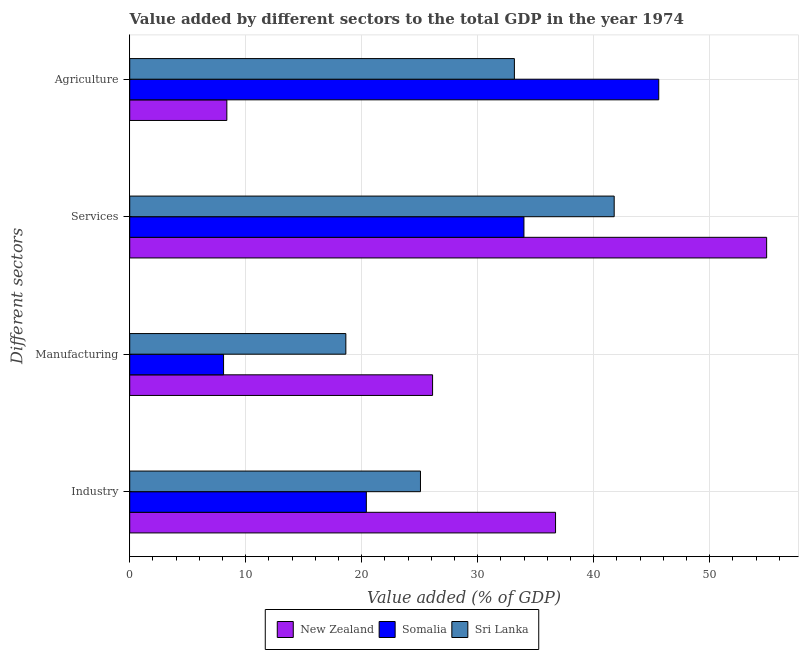How many different coloured bars are there?
Provide a short and direct response. 3. How many groups of bars are there?
Your answer should be compact. 4. Are the number of bars per tick equal to the number of legend labels?
Your response must be concise. Yes. How many bars are there on the 2nd tick from the bottom?
Provide a short and direct response. 3. What is the label of the 4th group of bars from the top?
Provide a succinct answer. Industry. What is the value added by manufacturing sector in New Zealand?
Your response must be concise. 26.11. Across all countries, what is the maximum value added by services sector?
Keep it short and to the point. 54.91. Across all countries, what is the minimum value added by services sector?
Make the answer very short. 33.99. In which country was the value added by services sector maximum?
Your response must be concise. New Zealand. In which country was the value added by services sector minimum?
Ensure brevity in your answer.  Somalia. What is the total value added by agricultural sector in the graph?
Offer a terse response. 87.15. What is the difference between the value added by industrial sector in Somalia and that in New Zealand?
Offer a very short reply. -16.31. What is the difference between the value added by industrial sector in Sri Lanka and the value added by manufacturing sector in Somalia?
Provide a short and direct response. 16.98. What is the average value added by agricultural sector per country?
Your response must be concise. 29.05. What is the difference between the value added by manufacturing sector and value added by services sector in Sri Lanka?
Offer a terse response. -23.14. In how many countries, is the value added by agricultural sector greater than 6 %?
Give a very brief answer. 3. What is the ratio of the value added by services sector in Sri Lanka to that in New Zealand?
Offer a terse response. 0.76. Is the difference between the value added by agricultural sector in New Zealand and Sri Lanka greater than the difference between the value added by industrial sector in New Zealand and Sri Lanka?
Provide a short and direct response. No. What is the difference between the highest and the second highest value added by agricultural sector?
Make the answer very short. 12.45. What is the difference between the highest and the lowest value added by services sector?
Give a very brief answer. 20.93. Is the sum of the value added by industrial sector in New Zealand and Somalia greater than the maximum value added by manufacturing sector across all countries?
Ensure brevity in your answer.  Yes. Is it the case that in every country, the sum of the value added by services sector and value added by agricultural sector is greater than the sum of value added by manufacturing sector and value added by industrial sector?
Keep it short and to the point. Yes. What does the 2nd bar from the top in Agriculture represents?
Make the answer very short. Somalia. What does the 1st bar from the bottom in Agriculture represents?
Provide a succinct answer. New Zealand. How many bars are there?
Your response must be concise. 12. Are all the bars in the graph horizontal?
Your answer should be very brief. Yes. How many countries are there in the graph?
Make the answer very short. 3. What is the difference between two consecutive major ticks on the X-axis?
Make the answer very short. 10. Are the values on the major ticks of X-axis written in scientific E-notation?
Your response must be concise. No. Does the graph contain any zero values?
Keep it short and to the point. No. Does the graph contain grids?
Provide a short and direct response. Yes. Where does the legend appear in the graph?
Give a very brief answer. Bottom center. What is the title of the graph?
Your answer should be compact. Value added by different sectors to the total GDP in the year 1974. Does "Canada" appear as one of the legend labels in the graph?
Keep it short and to the point. No. What is the label or title of the X-axis?
Give a very brief answer. Value added (% of GDP). What is the label or title of the Y-axis?
Make the answer very short. Different sectors. What is the Value added (% of GDP) in New Zealand in Industry?
Ensure brevity in your answer.  36.71. What is the Value added (% of GDP) in Somalia in Industry?
Provide a short and direct response. 20.4. What is the Value added (% of GDP) of Sri Lanka in Industry?
Provide a succinct answer. 25.07. What is the Value added (% of GDP) in New Zealand in Manufacturing?
Provide a succinct answer. 26.11. What is the Value added (% of GDP) of Somalia in Manufacturing?
Give a very brief answer. 8.09. What is the Value added (% of GDP) in Sri Lanka in Manufacturing?
Keep it short and to the point. 18.63. What is the Value added (% of GDP) of New Zealand in Services?
Your answer should be very brief. 54.91. What is the Value added (% of GDP) of Somalia in Services?
Ensure brevity in your answer.  33.99. What is the Value added (% of GDP) in Sri Lanka in Services?
Your response must be concise. 41.77. What is the Value added (% of GDP) of New Zealand in Agriculture?
Your response must be concise. 8.37. What is the Value added (% of GDP) of Somalia in Agriculture?
Keep it short and to the point. 45.61. What is the Value added (% of GDP) in Sri Lanka in Agriculture?
Your answer should be very brief. 33.16. Across all Different sectors, what is the maximum Value added (% of GDP) of New Zealand?
Ensure brevity in your answer.  54.91. Across all Different sectors, what is the maximum Value added (% of GDP) in Somalia?
Offer a very short reply. 45.61. Across all Different sectors, what is the maximum Value added (% of GDP) in Sri Lanka?
Keep it short and to the point. 41.77. Across all Different sectors, what is the minimum Value added (% of GDP) in New Zealand?
Provide a short and direct response. 8.37. Across all Different sectors, what is the minimum Value added (% of GDP) in Somalia?
Provide a short and direct response. 8.09. Across all Different sectors, what is the minimum Value added (% of GDP) in Sri Lanka?
Make the answer very short. 18.63. What is the total Value added (% of GDP) in New Zealand in the graph?
Make the answer very short. 126.11. What is the total Value added (% of GDP) in Somalia in the graph?
Ensure brevity in your answer.  108.09. What is the total Value added (% of GDP) of Sri Lanka in the graph?
Ensure brevity in your answer.  118.63. What is the difference between the Value added (% of GDP) in New Zealand in Industry and that in Manufacturing?
Ensure brevity in your answer.  10.6. What is the difference between the Value added (% of GDP) in Somalia in Industry and that in Manufacturing?
Your response must be concise. 12.31. What is the difference between the Value added (% of GDP) of Sri Lanka in Industry and that in Manufacturing?
Offer a very short reply. 6.43. What is the difference between the Value added (% of GDP) of New Zealand in Industry and that in Services?
Give a very brief answer. -18.2. What is the difference between the Value added (% of GDP) in Somalia in Industry and that in Services?
Your response must be concise. -13.59. What is the difference between the Value added (% of GDP) of Sri Lanka in Industry and that in Services?
Your response must be concise. -16.7. What is the difference between the Value added (% of GDP) in New Zealand in Industry and that in Agriculture?
Offer a very short reply. 28.34. What is the difference between the Value added (% of GDP) in Somalia in Industry and that in Agriculture?
Your answer should be very brief. -25.21. What is the difference between the Value added (% of GDP) in Sri Lanka in Industry and that in Agriculture?
Provide a short and direct response. -8.1. What is the difference between the Value added (% of GDP) of New Zealand in Manufacturing and that in Services?
Your answer should be very brief. -28.8. What is the difference between the Value added (% of GDP) of Somalia in Manufacturing and that in Services?
Provide a short and direct response. -25.9. What is the difference between the Value added (% of GDP) in Sri Lanka in Manufacturing and that in Services?
Offer a terse response. -23.14. What is the difference between the Value added (% of GDP) of New Zealand in Manufacturing and that in Agriculture?
Make the answer very short. 17.74. What is the difference between the Value added (% of GDP) of Somalia in Manufacturing and that in Agriculture?
Provide a succinct answer. -37.52. What is the difference between the Value added (% of GDP) in Sri Lanka in Manufacturing and that in Agriculture?
Offer a very short reply. -14.53. What is the difference between the Value added (% of GDP) of New Zealand in Services and that in Agriculture?
Your answer should be compact. 46.54. What is the difference between the Value added (% of GDP) in Somalia in Services and that in Agriculture?
Provide a short and direct response. -11.62. What is the difference between the Value added (% of GDP) of Sri Lanka in Services and that in Agriculture?
Your response must be concise. 8.6. What is the difference between the Value added (% of GDP) of New Zealand in Industry and the Value added (% of GDP) of Somalia in Manufacturing?
Make the answer very short. 28.62. What is the difference between the Value added (% of GDP) in New Zealand in Industry and the Value added (% of GDP) in Sri Lanka in Manufacturing?
Provide a short and direct response. 18.08. What is the difference between the Value added (% of GDP) of Somalia in Industry and the Value added (% of GDP) of Sri Lanka in Manufacturing?
Your answer should be compact. 1.77. What is the difference between the Value added (% of GDP) in New Zealand in Industry and the Value added (% of GDP) in Somalia in Services?
Give a very brief answer. 2.73. What is the difference between the Value added (% of GDP) in New Zealand in Industry and the Value added (% of GDP) in Sri Lanka in Services?
Provide a short and direct response. -5.06. What is the difference between the Value added (% of GDP) in Somalia in Industry and the Value added (% of GDP) in Sri Lanka in Services?
Ensure brevity in your answer.  -21.37. What is the difference between the Value added (% of GDP) of New Zealand in Industry and the Value added (% of GDP) of Somalia in Agriculture?
Your response must be concise. -8.9. What is the difference between the Value added (% of GDP) of New Zealand in Industry and the Value added (% of GDP) of Sri Lanka in Agriculture?
Provide a succinct answer. 3.55. What is the difference between the Value added (% of GDP) in Somalia in Industry and the Value added (% of GDP) in Sri Lanka in Agriculture?
Keep it short and to the point. -12.76. What is the difference between the Value added (% of GDP) in New Zealand in Manufacturing and the Value added (% of GDP) in Somalia in Services?
Make the answer very short. -7.88. What is the difference between the Value added (% of GDP) of New Zealand in Manufacturing and the Value added (% of GDP) of Sri Lanka in Services?
Your response must be concise. -15.66. What is the difference between the Value added (% of GDP) in Somalia in Manufacturing and the Value added (% of GDP) in Sri Lanka in Services?
Your response must be concise. -33.68. What is the difference between the Value added (% of GDP) in New Zealand in Manufacturing and the Value added (% of GDP) in Somalia in Agriculture?
Your response must be concise. -19.5. What is the difference between the Value added (% of GDP) of New Zealand in Manufacturing and the Value added (% of GDP) of Sri Lanka in Agriculture?
Offer a very short reply. -7.05. What is the difference between the Value added (% of GDP) of Somalia in Manufacturing and the Value added (% of GDP) of Sri Lanka in Agriculture?
Provide a short and direct response. -25.07. What is the difference between the Value added (% of GDP) of New Zealand in Services and the Value added (% of GDP) of Somalia in Agriculture?
Provide a succinct answer. 9.3. What is the difference between the Value added (% of GDP) in New Zealand in Services and the Value added (% of GDP) in Sri Lanka in Agriculture?
Keep it short and to the point. 21.75. What is the difference between the Value added (% of GDP) of Somalia in Services and the Value added (% of GDP) of Sri Lanka in Agriculture?
Your response must be concise. 0.82. What is the average Value added (% of GDP) in New Zealand per Different sectors?
Ensure brevity in your answer.  31.53. What is the average Value added (% of GDP) of Somalia per Different sectors?
Offer a terse response. 27.02. What is the average Value added (% of GDP) of Sri Lanka per Different sectors?
Ensure brevity in your answer.  29.66. What is the difference between the Value added (% of GDP) of New Zealand and Value added (% of GDP) of Somalia in Industry?
Your response must be concise. 16.31. What is the difference between the Value added (% of GDP) of New Zealand and Value added (% of GDP) of Sri Lanka in Industry?
Your answer should be very brief. 11.65. What is the difference between the Value added (% of GDP) in Somalia and Value added (% of GDP) in Sri Lanka in Industry?
Give a very brief answer. -4.67. What is the difference between the Value added (% of GDP) of New Zealand and Value added (% of GDP) of Somalia in Manufacturing?
Make the answer very short. 18.02. What is the difference between the Value added (% of GDP) in New Zealand and Value added (% of GDP) in Sri Lanka in Manufacturing?
Provide a short and direct response. 7.48. What is the difference between the Value added (% of GDP) in Somalia and Value added (% of GDP) in Sri Lanka in Manufacturing?
Ensure brevity in your answer.  -10.54. What is the difference between the Value added (% of GDP) of New Zealand and Value added (% of GDP) of Somalia in Services?
Your answer should be compact. 20.93. What is the difference between the Value added (% of GDP) of New Zealand and Value added (% of GDP) of Sri Lanka in Services?
Provide a short and direct response. 13.14. What is the difference between the Value added (% of GDP) of Somalia and Value added (% of GDP) of Sri Lanka in Services?
Keep it short and to the point. -7.78. What is the difference between the Value added (% of GDP) in New Zealand and Value added (% of GDP) in Somalia in Agriculture?
Give a very brief answer. -37.24. What is the difference between the Value added (% of GDP) of New Zealand and Value added (% of GDP) of Sri Lanka in Agriculture?
Offer a terse response. -24.79. What is the difference between the Value added (% of GDP) of Somalia and Value added (% of GDP) of Sri Lanka in Agriculture?
Your response must be concise. 12.45. What is the ratio of the Value added (% of GDP) in New Zealand in Industry to that in Manufacturing?
Provide a succinct answer. 1.41. What is the ratio of the Value added (% of GDP) of Somalia in Industry to that in Manufacturing?
Make the answer very short. 2.52. What is the ratio of the Value added (% of GDP) of Sri Lanka in Industry to that in Manufacturing?
Provide a succinct answer. 1.35. What is the ratio of the Value added (% of GDP) in New Zealand in Industry to that in Services?
Give a very brief answer. 0.67. What is the ratio of the Value added (% of GDP) in Somalia in Industry to that in Services?
Offer a terse response. 0.6. What is the ratio of the Value added (% of GDP) of Sri Lanka in Industry to that in Services?
Your response must be concise. 0.6. What is the ratio of the Value added (% of GDP) in New Zealand in Industry to that in Agriculture?
Provide a short and direct response. 4.38. What is the ratio of the Value added (% of GDP) of Somalia in Industry to that in Agriculture?
Offer a very short reply. 0.45. What is the ratio of the Value added (% of GDP) in Sri Lanka in Industry to that in Agriculture?
Your response must be concise. 0.76. What is the ratio of the Value added (% of GDP) in New Zealand in Manufacturing to that in Services?
Provide a succinct answer. 0.48. What is the ratio of the Value added (% of GDP) in Somalia in Manufacturing to that in Services?
Give a very brief answer. 0.24. What is the ratio of the Value added (% of GDP) in Sri Lanka in Manufacturing to that in Services?
Your response must be concise. 0.45. What is the ratio of the Value added (% of GDP) of New Zealand in Manufacturing to that in Agriculture?
Your answer should be compact. 3.12. What is the ratio of the Value added (% of GDP) in Somalia in Manufacturing to that in Agriculture?
Offer a very short reply. 0.18. What is the ratio of the Value added (% of GDP) in Sri Lanka in Manufacturing to that in Agriculture?
Make the answer very short. 0.56. What is the ratio of the Value added (% of GDP) in New Zealand in Services to that in Agriculture?
Give a very brief answer. 6.56. What is the ratio of the Value added (% of GDP) of Somalia in Services to that in Agriculture?
Give a very brief answer. 0.75. What is the ratio of the Value added (% of GDP) of Sri Lanka in Services to that in Agriculture?
Ensure brevity in your answer.  1.26. What is the difference between the highest and the second highest Value added (% of GDP) in New Zealand?
Give a very brief answer. 18.2. What is the difference between the highest and the second highest Value added (% of GDP) of Somalia?
Your response must be concise. 11.62. What is the difference between the highest and the second highest Value added (% of GDP) of Sri Lanka?
Provide a succinct answer. 8.6. What is the difference between the highest and the lowest Value added (% of GDP) of New Zealand?
Your answer should be very brief. 46.54. What is the difference between the highest and the lowest Value added (% of GDP) in Somalia?
Your response must be concise. 37.52. What is the difference between the highest and the lowest Value added (% of GDP) of Sri Lanka?
Offer a very short reply. 23.14. 